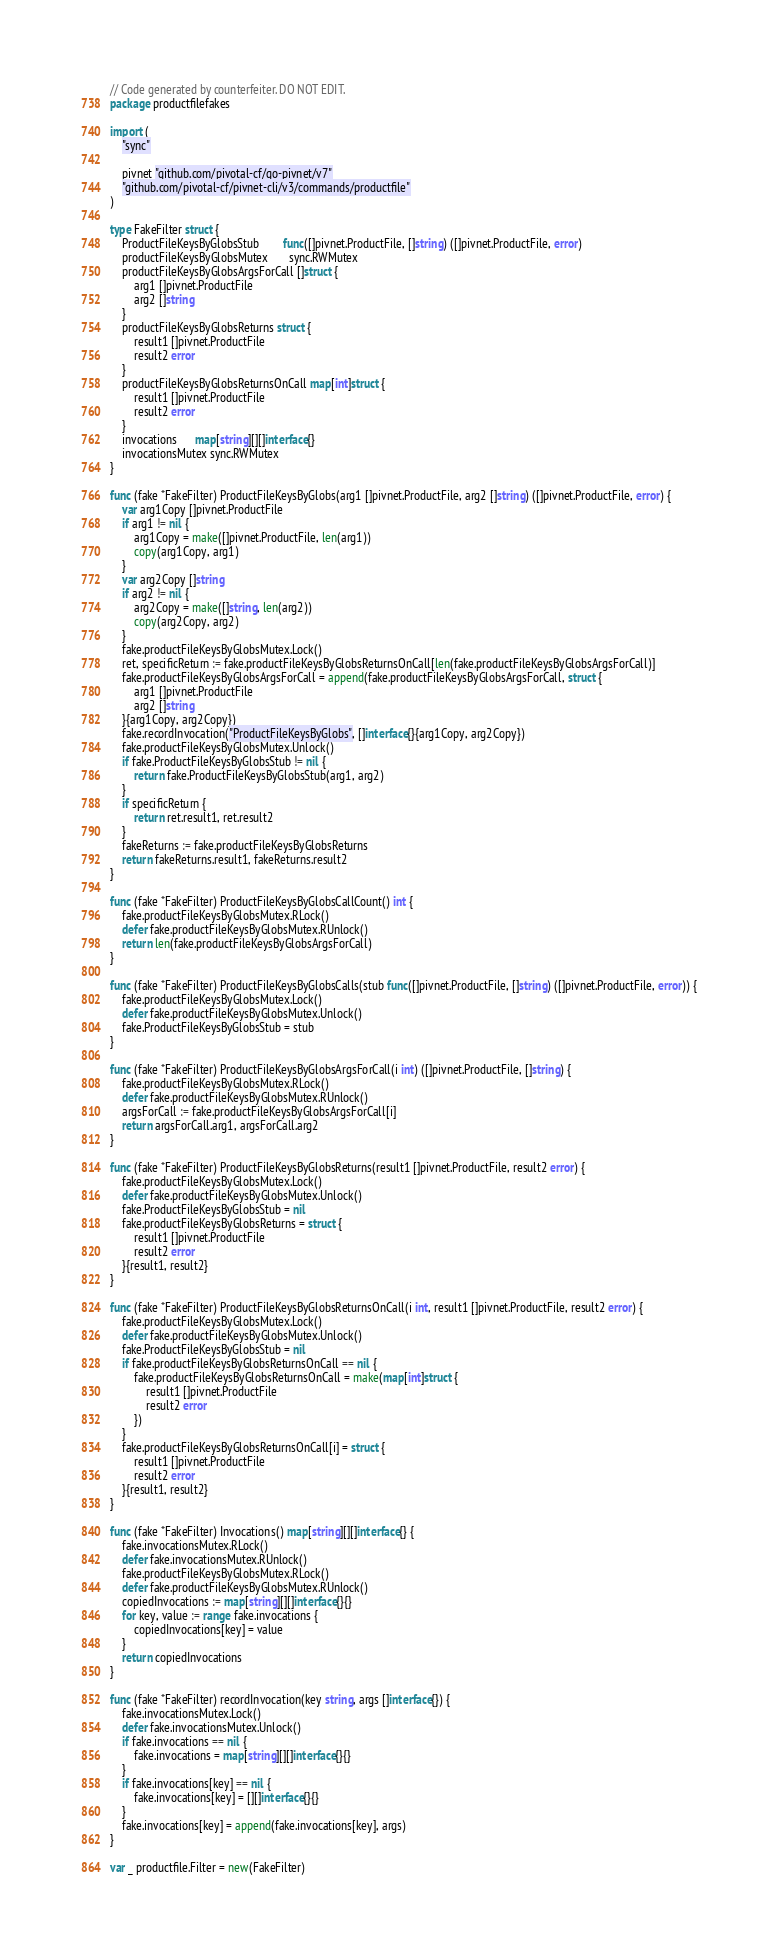Convert code to text. <code><loc_0><loc_0><loc_500><loc_500><_Go_>// Code generated by counterfeiter. DO NOT EDIT.
package productfilefakes

import (
	"sync"

	pivnet "github.com/pivotal-cf/go-pivnet/v7"
	"github.com/pivotal-cf/pivnet-cli/v3/commands/productfile"
)

type FakeFilter struct {
	ProductFileKeysByGlobsStub        func([]pivnet.ProductFile, []string) ([]pivnet.ProductFile, error)
	productFileKeysByGlobsMutex       sync.RWMutex
	productFileKeysByGlobsArgsForCall []struct {
		arg1 []pivnet.ProductFile
		arg2 []string
	}
	productFileKeysByGlobsReturns struct {
		result1 []pivnet.ProductFile
		result2 error
	}
	productFileKeysByGlobsReturnsOnCall map[int]struct {
		result1 []pivnet.ProductFile
		result2 error
	}
	invocations      map[string][][]interface{}
	invocationsMutex sync.RWMutex
}

func (fake *FakeFilter) ProductFileKeysByGlobs(arg1 []pivnet.ProductFile, arg2 []string) ([]pivnet.ProductFile, error) {
	var arg1Copy []pivnet.ProductFile
	if arg1 != nil {
		arg1Copy = make([]pivnet.ProductFile, len(arg1))
		copy(arg1Copy, arg1)
	}
	var arg2Copy []string
	if arg2 != nil {
		arg2Copy = make([]string, len(arg2))
		copy(arg2Copy, arg2)
	}
	fake.productFileKeysByGlobsMutex.Lock()
	ret, specificReturn := fake.productFileKeysByGlobsReturnsOnCall[len(fake.productFileKeysByGlobsArgsForCall)]
	fake.productFileKeysByGlobsArgsForCall = append(fake.productFileKeysByGlobsArgsForCall, struct {
		arg1 []pivnet.ProductFile
		arg2 []string
	}{arg1Copy, arg2Copy})
	fake.recordInvocation("ProductFileKeysByGlobs", []interface{}{arg1Copy, arg2Copy})
	fake.productFileKeysByGlobsMutex.Unlock()
	if fake.ProductFileKeysByGlobsStub != nil {
		return fake.ProductFileKeysByGlobsStub(arg1, arg2)
	}
	if specificReturn {
		return ret.result1, ret.result2
	}
	fakeReturns := fake.productFileKeysByGlobsReturns
	return fakeReturns.result1, fakeReturns.result2
}

func (fake *FakeFilter) ProductFileKeysByGlobsCallCount() int {
	fake.productFileKeysByGlobsMutex.RLock()
	defer fake.productFileKeysByGlobsMutex.RUnlock()
	return len(fake.productFileKeysByGlobsArgsForCall)
}

func (fake *FakeFilter) ProductFileKeysByGlobsCalls(stub func([]pivnet.ProductFile, []string) ([]pivnet.ProductFile, error)) {
	fake.productFileKeysByGlobsMutex.Lock()
	defer fake.productFileKeysByGlobsMutex.Unlock()
	fake.ProductFileKeysByGlobsStub = stub
}

func (fake *FakeFilter) ProductFileKeysByGlobsArgsForCall(i int) ([]pivnet.ProductFile, []string) {
	fake.productFileKeysByGlobsMutex.RLock()
	defer fake.productFileKeysByGlobsMutex.RUnlock()
	argsForCall := fake.productFileKeysByGlobsArgsForCall[i]
	return argsForCall.arg1, argsForCall.arg2
}

func (fake *FakeFilter) ProductFileKeysByGlobsReturns(result1 []pivnet.ProductFile, result2 error) {
	fake.productFileKeysByGlobsMutex.Lock()
	defer fake.productFileKeysByGlobsMutex.Unlock()
	fake.ProductFileKeysByGlobsStub = nil
	fake.productFileKeysByGlobsReturns = struct {
		result1 []pivnet.ProductFile
		result2 error
	}{result1, result2}
}

func (fake *FakeFilter) ProductFileKeysByGlobsReturnsOnCall(i int, result1 []pivnet.ProductFile, result2 error) {
	fake.productFileKeysByGlobsMutex.Lock()
	defer fake.productFileKeysByGlobsMutex.Unlock()
	fake.ProductFileKeysByGlobsStub = nil
	if fake.productFileKeysByGlobsReturnsOnCall == nil {
		fake.productFileKeysByGlobsReturnsOnCall = make(map[int]struct {
			result1 []pivnet.ProductFile
			result2 error
		})
	}
	fake.productFileKeysByGlobsReturnsOnCall[i] = struct {
		result1 []pivnet.ProductFile
		result2 error
	}{result1, result2}
}

func (fake *FakeFilter) Invocations() map[string][][]interface{} {
	fake.invocationsMutex.RLock()
	defer fake.invocationsMutex.RUnlock()
	fake.productFileKeysByGlobsMutex.RLock()
	defer fake.productFileKeysByGlobsMutex.RUnlock()
	copiedInvocations := map[string][][]interface{}{}
	for key, value := range fake.invocations {
		copiedInvocations[key] = value
	}
	return copiedInvocations
}

func (fake *FakeFilter) recordInvocation(key string, args []interface{}) {
	fake.invocationsMutex.Lock()
	defer fake.invocationsMutex.Unlock()
	if fake.invocations == nil {
		fake.invocations = map[string][][]interface{}{}
	}
	if fake.invocations[key] == nil {
		fake.invocations[key] = [][]interface{}{}
	}
	fake.invocations[key] = append(fake.invocations[key], args)
}

var _ productfile.Filter = new(FakeFilter)
</code> 